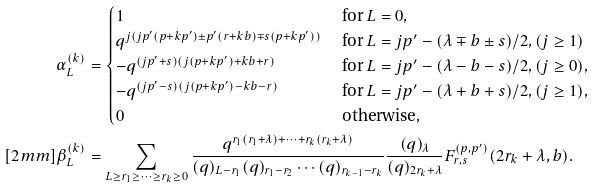Convert formula to latex. <formula><loc_0><loc_0><loc_500><loc_500>\alpha ^ { ( k ) } _ { L } & = \begin{cases} 1 & \text { for } L = 0 , \\ q ^ { j ( j p ^ { \prime } ( p + k p ^ { \prime } ) \pm p ^ { \prime } ( r + k b ) \mp s ( p + k p ^ { \prime } ) ) } & \text { for } L = j p ^ { \prime } - ( \lambda \mp b \pm s ) / 2 , ( j \geq 1 ) \\ - q ^ { ( j p ^ { \prime } + s ) ( j ( p + k p ^ { \prime } ) + k b + r ) } & \text { for } L = j p ^ { \prime } - ( \lambda - b - s ) / 2 , ( j \geq 0 ) , \\ - q ^ { ( j p ^ { \prime } - s ) ( j ( p + k p ^ { \prime } ) - k b - r ) } & \text { for } L = j p ^ { \prime } - ( \lambda + b + s ) / 2 , ( j \geq 1 ) , \\ 0 & \text { otherwise} , \end{cases} \\ [ 2 m m ] \beta ^ { ( k ) } _ { L } & = \sum _ { L \geq r _ { 1 } \geq \dots \geq r _ { k } \geq 0 } \frac { q ^ { r _ { 1 } ( r _ { 1 } + \lambda ) + \cdots + r _ { k } ( r _ { k } + \lambda ) } } { ( q ) _ { L - r _ { 1 } } ( q ) _ { r _ { 1 } - r _ { 2 } } \cdots ( q ) _ { r _ { k - 1 } - r _ { k } } } \frac { ( q ) _ { \lambda } } { ( q ) _ { 2 r _ { k } + \lambda } } F _ { r , s } ^ { ( p , p ^ { \prime } ) } ( 2 r _ { k } + \lambda , b ) .</formula> 